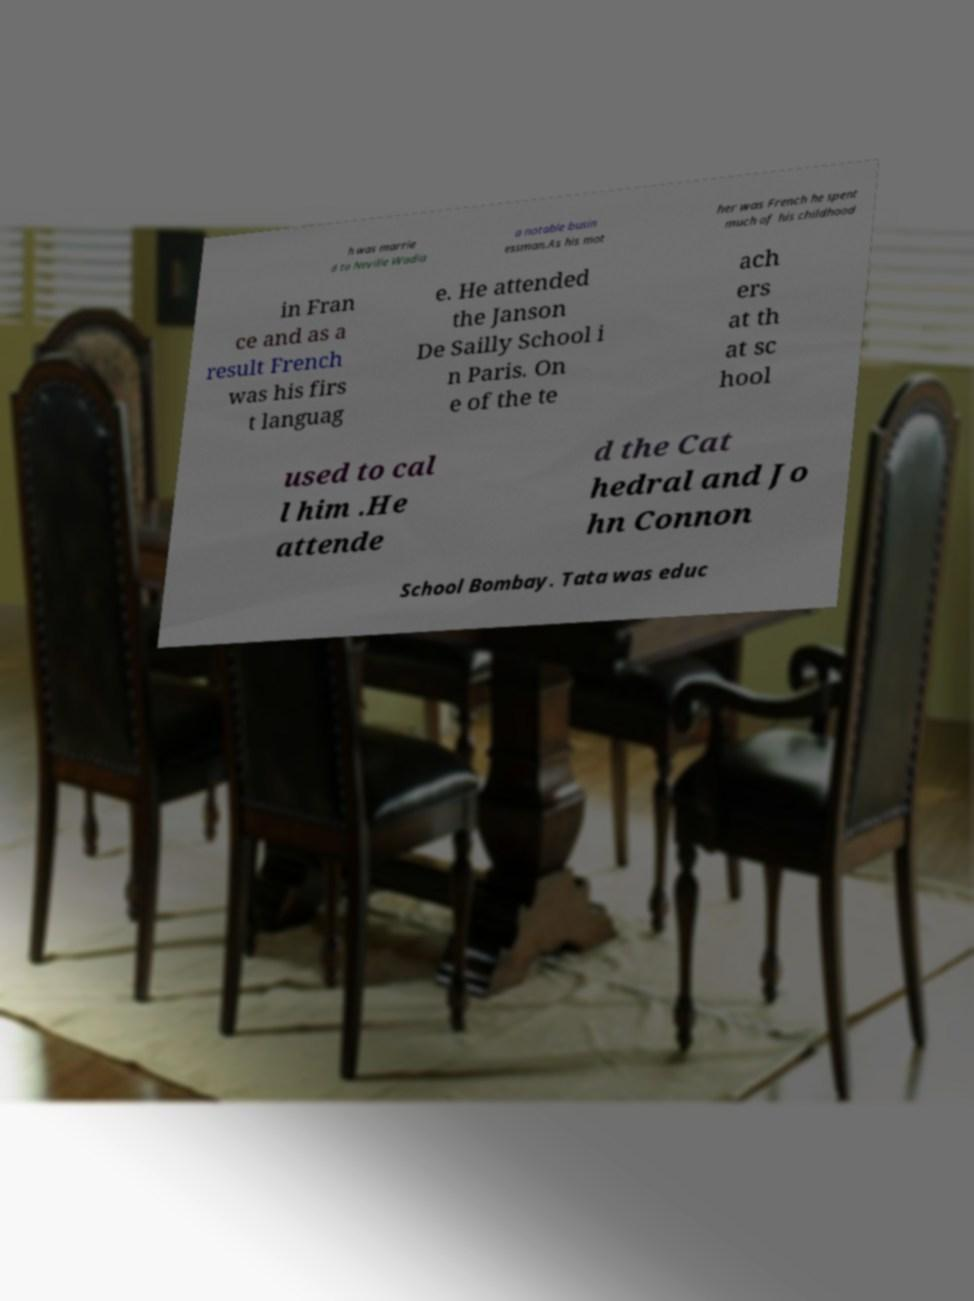For documentation purposes, I need the text within this image transcribed. Could you provide that? h was marrie d to Neville Wadia a notable busin essman.As his mot her was French he spent much of his childhood in Fran ce and as a result French was his firs t languag e. He attended the Janson De Sailly School i n Paris. On e of the te ach ers at th at sc hool used to cal l him .He attende d the Cat hedral and Jo hn Connon School Bombay. Tata was educ 